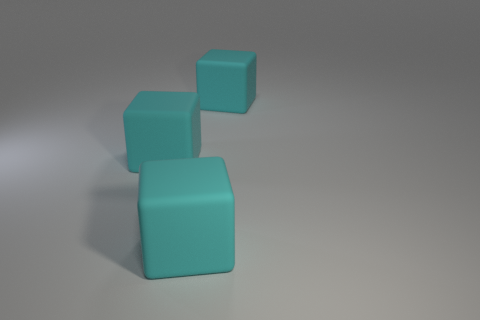Subtract all cyan cubes. How many were subtracted if there are1cyan cubes left? 2 Subtract all gray blocks. Subtract all brown spheres. How many blocks are left? 3 Add 1 cyan blocks. How many objects exist? 4 Add 2 big matte blocks. How many big matte blocks are left? 5 Add 3 large things. How many large things exist? 6 Subtract 0 yellow cubes. How many objects are left? 3 